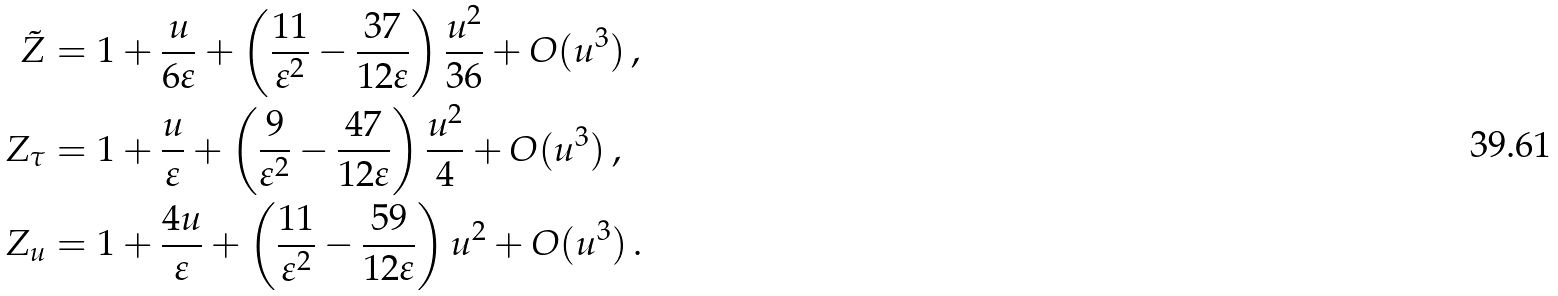<formula> <loc_0><loc_0><loc_500><loc_500>\tilde { Z } & = 1 + \frac { u } { 6 \varepsilon } + \left ( \frac { 1 1 } { \varepsilon ^ { 2 } } - \frac { 3 7 } { 1 2 \varepsilon } \right ) \frac { u ^ { 2 } } { 3 6 } + O ( u ^ { 3 } ) \, , \\ Z _ { \tau } & = 1 + \frac { u } { \varepsilon } + \left ( \frac { 9 } { \varepsilon ^ { 2 } } - \frac { 4 7 } { 1 2 \varepsilon } \right ) \frac { u ^ { 2 } } { 4 } + O ( u ^ { 3 } ) \, , \\ Z _ { u } & = 1 + \frac { 4 u } { \varepsilon } + \left ( \frac { 1 1 } { \varepsilon ^ { 2 } } - \frac { 5 9 } { 1 2 \varepsilon } \right ) u ^ { 2 } + O ( u ^ { 3 } ) \, .</formula> 